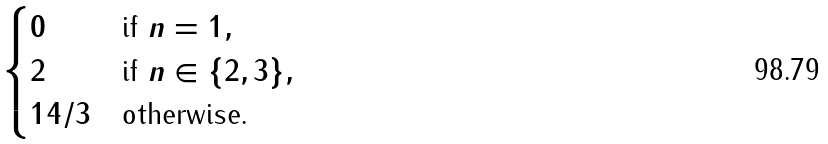Convert formula to latex. <formula><loc_0><loc_0><loc_500><loc_500>\begin{cases} 0 & \text {if $n=1$} , \\ 2 & \text {if $n\in\{2,3\}$} , \\ 1 4 / 3 & \text {otherwise.} \end{cases}</formula> 